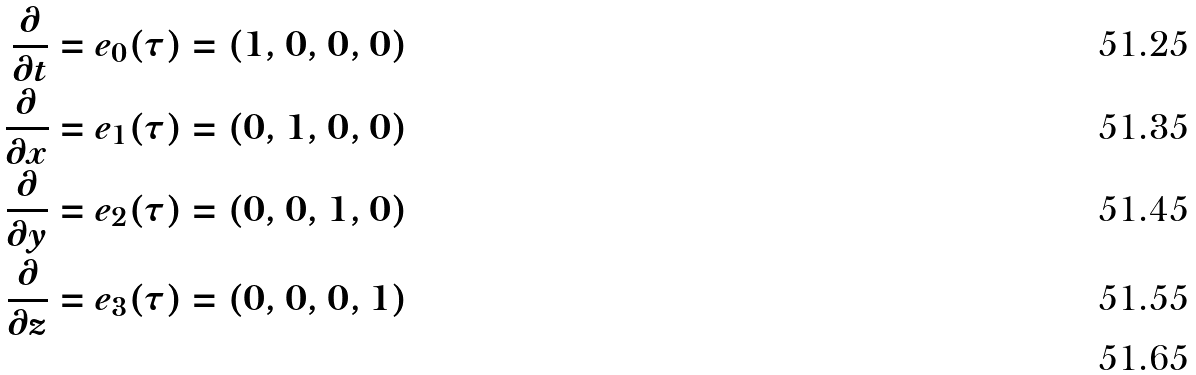Convert formula to latex. <formula><loc_0><loc_0><loc_500><loc_500>\frac { \partial } { \partial t } & = e _ { 0 } ( \tau ) = ( 1 , 0 , 0 , 0 ) \\ \frac { \partial } { \partial x } & = e _ { 1 } ( \tau ) = ( 0 , 1 , 0 , 0 ) \\ \frac { \partial } { \partial y } & = e _ { 2 } ( \tau ) = ( 0 , 0 , 1 , 0 ) \\ \frac { \partial } { \partial z } & = e _ { 3 } ( \tau ) = ( 0 , 0 , 0 , 1 ) \\</formula> 